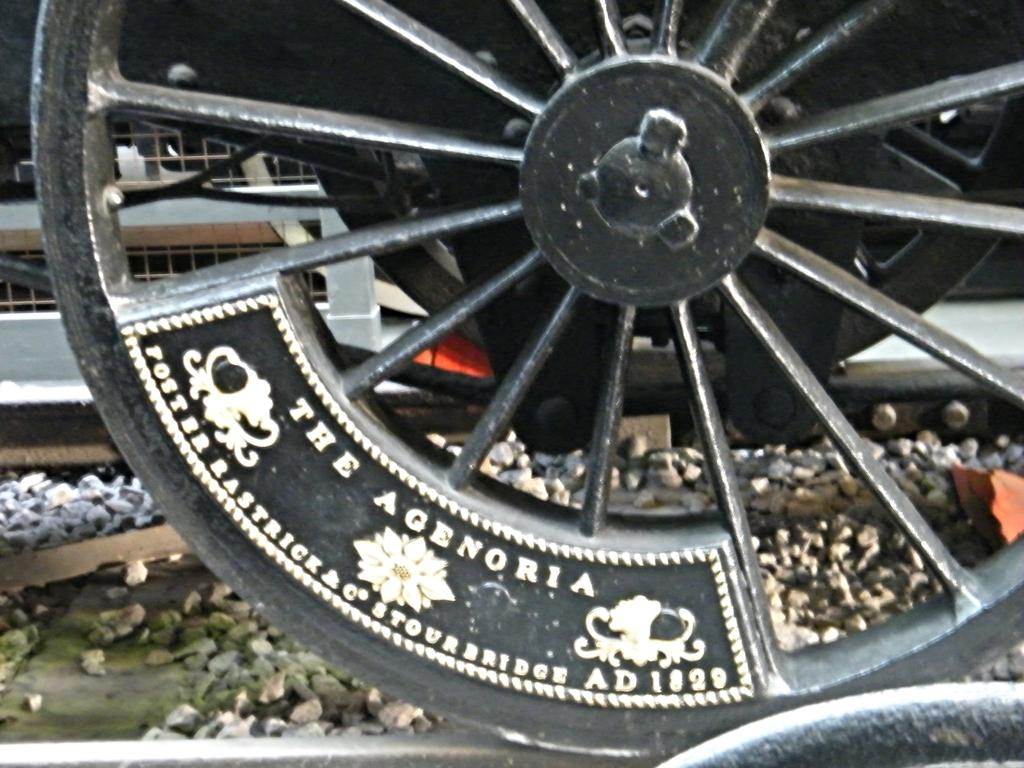<image>
Describe the image concisely. A metal wheel that says The Agenoria is on a train track. 